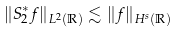Convert formula to latex. <formula><loc_0><loc_0><loc_500><loc_500>\| S ^ { * } _ { 2 } f \| _ { L ^ { 2 } ( \mathbb { R } ) } \lesssim \| f \| _ { H ^ { s } ( \mathbb { R } ) }</formula> 